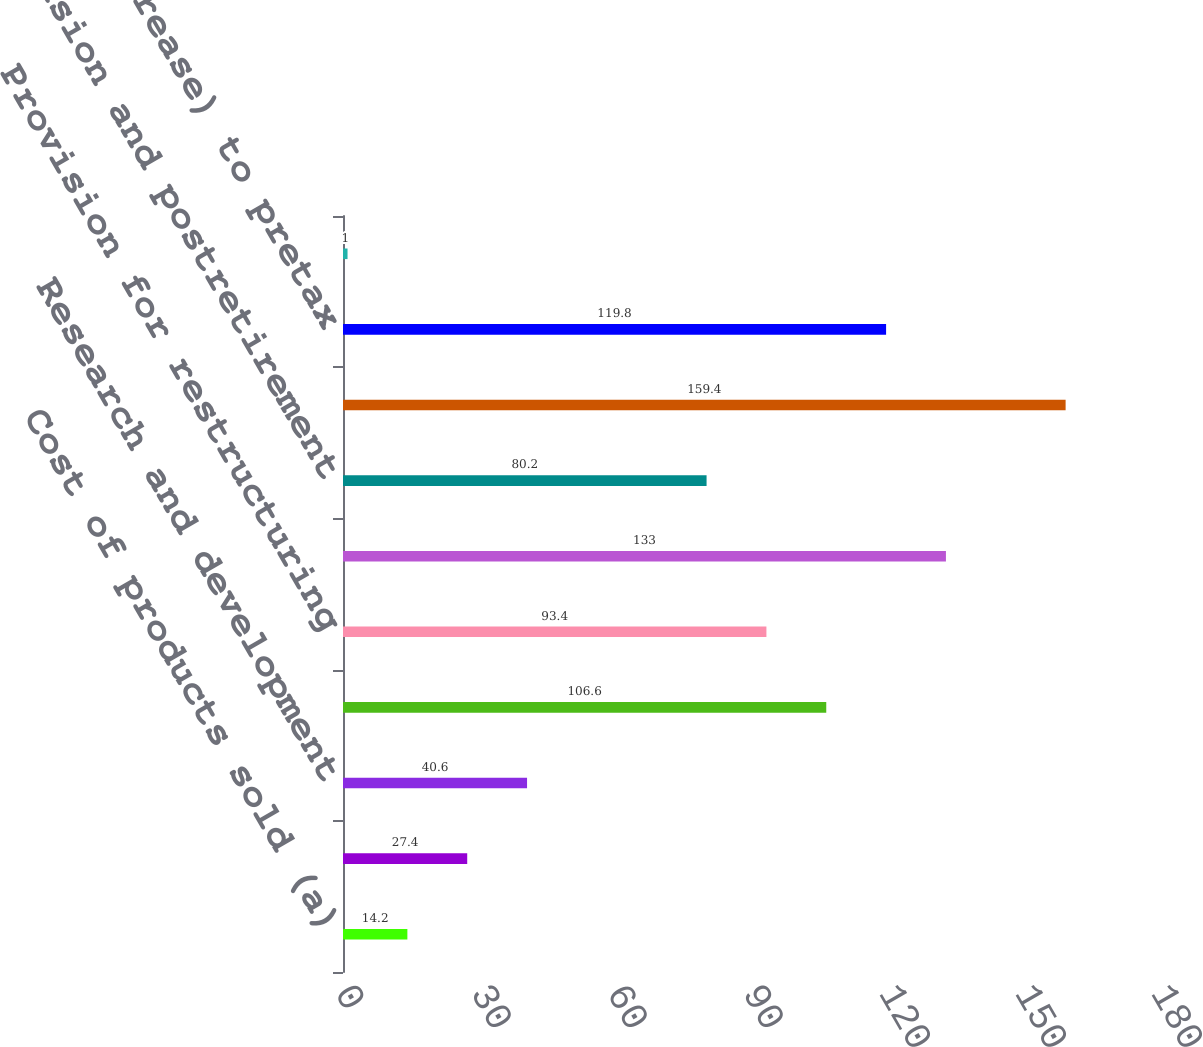Convert chart. <chart><loc_0><loc_0><loc_500><loc_500><bar_chart><fcel>Cost of products sold (a)<fcel>Site exit costs<fcel>Research and development<fcel>Loss/(gain) on equity<fcel>Provision for restructuring<fcel>Divestiture gains<fcel>Pension and postretirement<fcel>Other income (net)<fcel>Increase/(decrease) to pretax<fcel>Income taxes on items above<nl><fcel>14.2<fcel>27.4<fcel>40.6<fcel>106.6<fcel>93.4<fcel>133<fcel>80.2<fcel>159.4<fcel>119.8<fcel>1<nl></chart> 